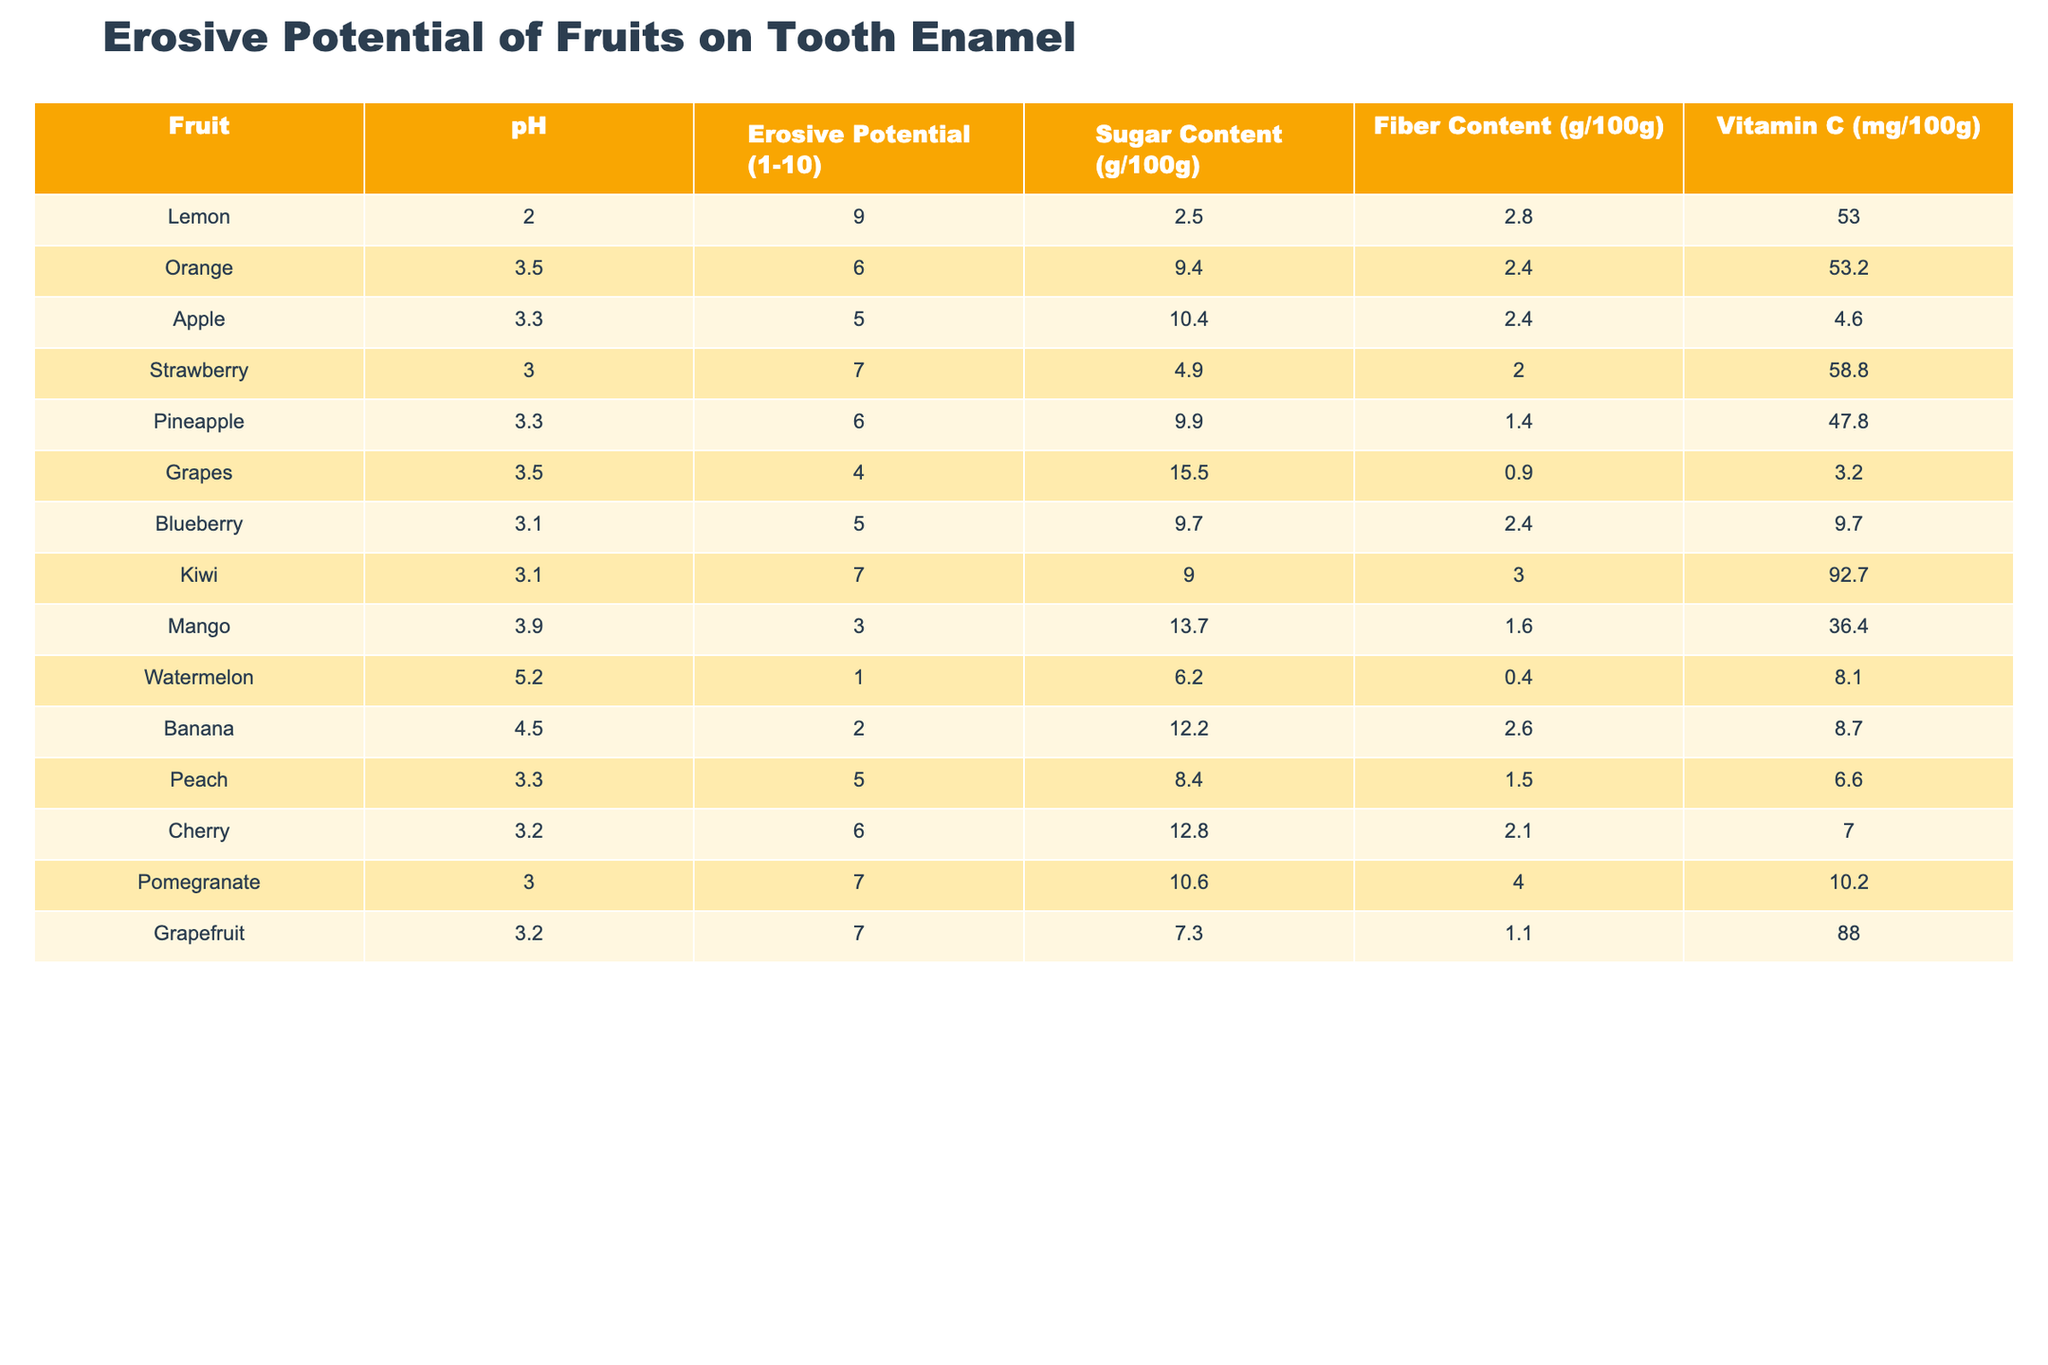What fruit has the highest erosive potential on tooth enamel? By examining the "Erosive Potential (1-10)" column, Lemon has the highest value at 9.
Answer: Lemon What is the pH of the fruit with the lowest erosive potential? The fruit with the lowest erosive potential is Watermelon, which has a pH of 5.2.
Answer: 5.2 Which fruit has the highest sugar content? Grapes contain the highest sugar content at 15.5 g/100g.
Answer: Grapes Is the erosive potential of oranges greater than that of apples? Oranges have an erosive potential of 6, while apples have 5, making the erosive potential of oranges greater.
Answer: Yes Which fruit has a higher fiber content: Strawberry or Kiwi? Strawberry has 2.0 g of fiber, while Kiwi has 3.0 g. Since 3.0 is greater than 2.0, Kiwi has a higher fiber content.
Answer: Kiwi What is the average pH of the fruits listed? The pH values are: 2.0, 3.5, 3.3, 3.0, 3.3, 3.5, 3.1, 3.1, 3.9, 5.2, 4.5, 3.3, 3.2, 3.0. Summing these gives 43.3. There are 14 fruits, so the average pH is 43.3/14 = 3.09.
Answer: 3.09 Does any fruit have a sugar content greater than its erosive potential? Comparing sugar content and erosive potential: Mango (13.7 g > 3), Grapes (15.5 g > 4), and Apple (10.4 g > 5) all have greater sugar content than their erosive potential ratings.
Answer: Yes What is the difference in erosive potential between Lemon and Watermelon? Lemon has an erosive potential of 9, while Watermelon has 1. The difference is 9 - 1 = 8.
Answer: 8 Which fruit provides the highest amount of Vitamin C? By checking the "Vitamin C (mg/100g)" column, Kiwi at 92.7 mg has the highest Vitamin C content.
Answer: Kiwi Which two fruits have the same erosive potential? Both Orange and Cherry have an erosive potential of 6.
Answer: Orange and Cherry 